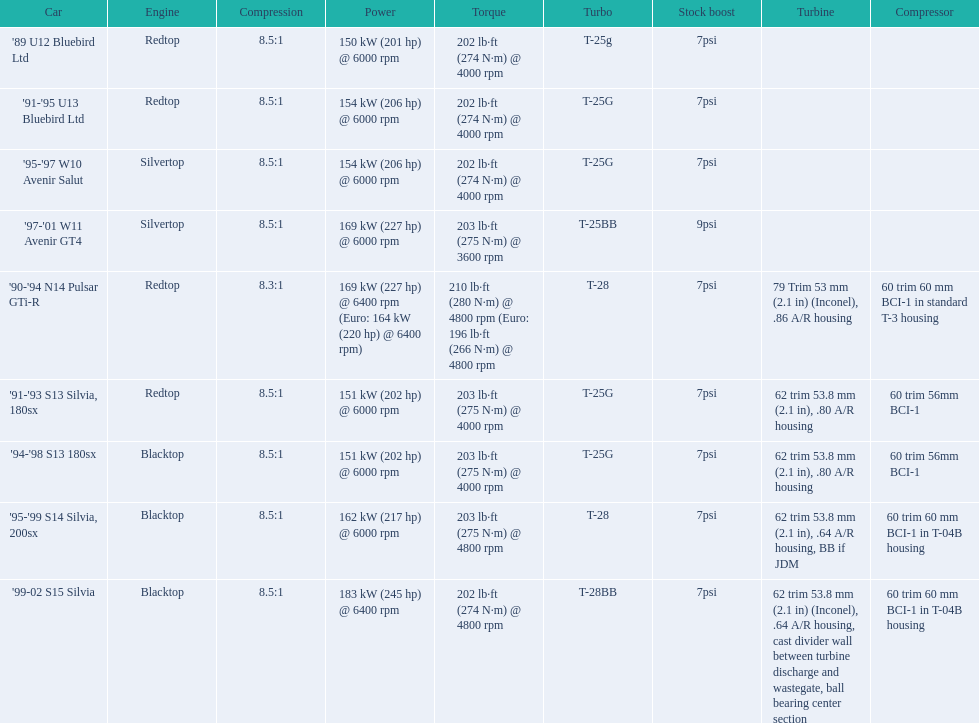What are the listed hp of the cars? 150 kW (201 hp) @ 6000 rpm, 154 kW (206 hp) @ 6000 rpm, 154 kW (206 hp) @ 6000 rpm, 169 kW (227 hp) @ 6000 rpm, 169 kW (227 hp) @ 6400 rpm (Euro: 164 kW (220 hp) @ 6400 rpm), 151 kW (202 hp) @ 6000 rpm, 151 kW (202 hp) @ 6000 rpm, 162 kW (217 hp) @ 6000 rpm, 183 kW (245 hp) @ 6400 rpm. Which is the only car with over 230 hp? '99-02 S15 Silvia. 